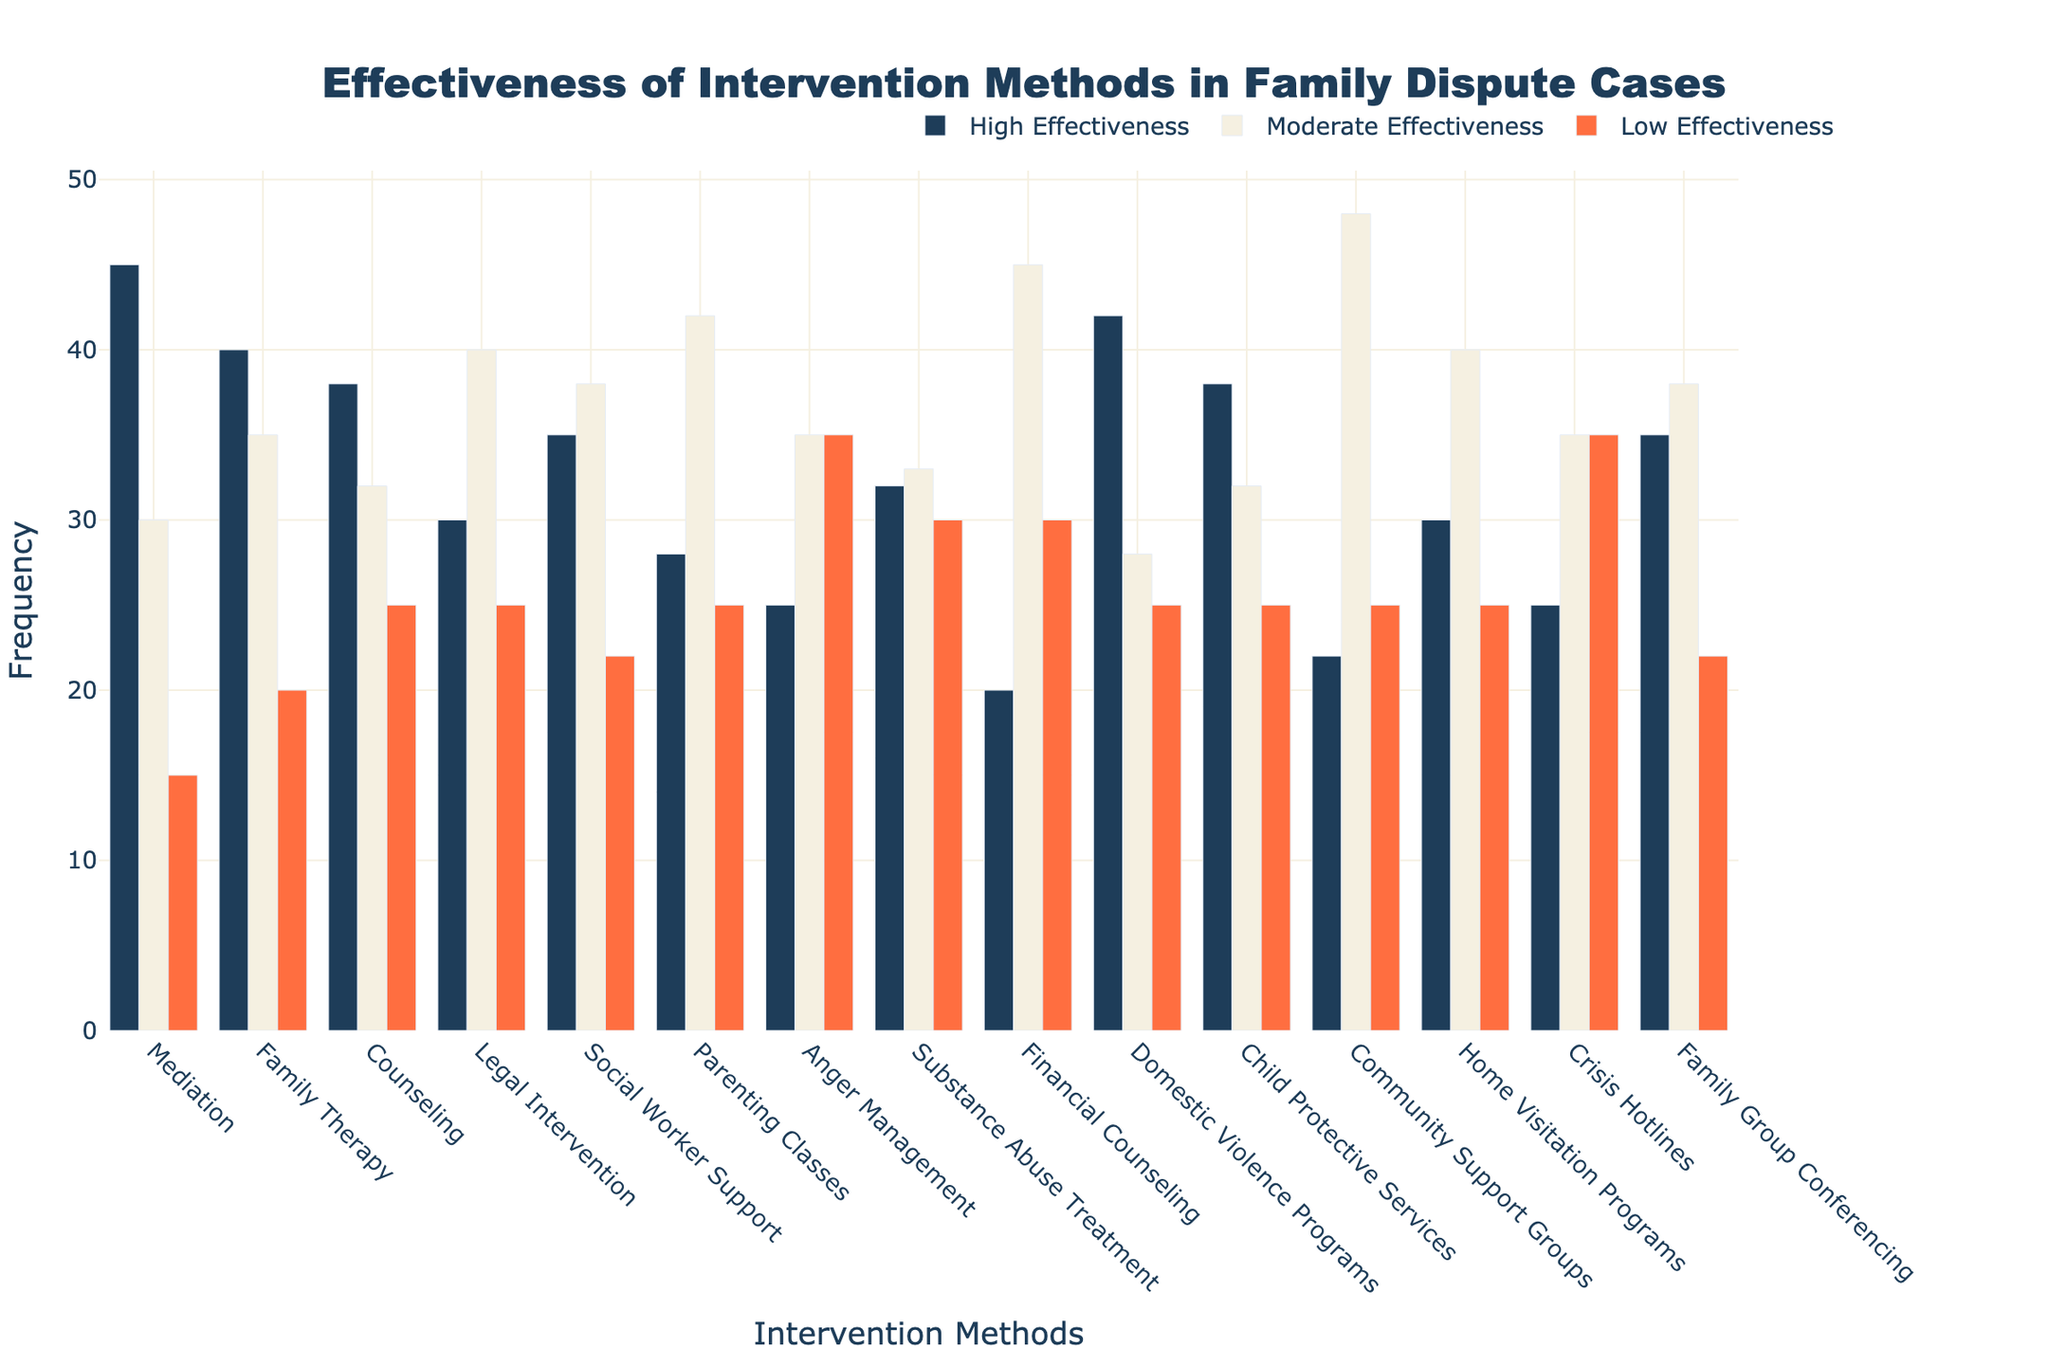How many intervention methods show moderate effectiveness higher than 35 cases? The figure shows the number of cases in different effectiveness categories for various intervention methods. Count the bars with 'Moderate Effectiveness' greater than 35. These bars belong to 'Parenting Classes' (42), 'Financial Counseling' (45), 'Community Support Groups' (48), and 'Home Visitation Programs' (40). This gives us a total of 4 methods.
Answer: 4 Which intervention method has the highest frequency of high effectiveness? Look at the height of the 'High Effectiveness' bars and find the tallest one. 'Mediation' has the tallest bar among all, with a value of 45.
Answer: Mediation Compare 'Social Worker Support' and 'Family Group Conferencing' in terms of their low effectiveness. Which one has a higher count? Focus on the 'Low Effectiveness' bars corresponding to 'Social Worker Support' and 'Family Group Conferencing'. Both methods have the same count of 22.
Answer: Equal What is the average frequency of high effectiveness for 'Mediation', 'Family Therapy', and 'Domestic Violence Programs'? Add the high effectiveness values for the three methods (45 for Mediation, 40 for Family Therapy, 42 for Domestic Violence Programs), and then divide by 3. (45 + 40 + 42) / 3 = 127 / 3 ≈ 42.33.
Answer: 42.33 Among Legal Intervention and Counseling, which method has a higher moderate effectiveness, and by how much? 'Legal Intervention' has 40 and 'Counseling' has 32 cases in moderate effectiveness. The difference is 40 - 32 = 8.
Answer: Legal Intervention, by 8 Which effectiveness category is consistently higher for most intervention methods? Compare the heights of the bars in all three categories for all intervention methods and identify the category that appears to be higher more often. 'Moderate Effectiveness' generally appears higher most frequently.
Answer: Moderate Effectiveness Calculate the combined frequency of low effectiveness for 'Child Protective Services' and 'Crisis Hotlines'. Add the low effectiveness frequencies of 'Child Protective Services' (25) and 'Crisis Hotlines' (35). (25 + 35 = 60).
Answer: 60 What is the total frequency of all effectiveness categories for 'Anger Management'? Sum the frequencies of high, moderate, and low effectiveness for 'Anger Management' (25 + 35 + 35). 25 + 35 + 35 = 95.
Answer: 95 